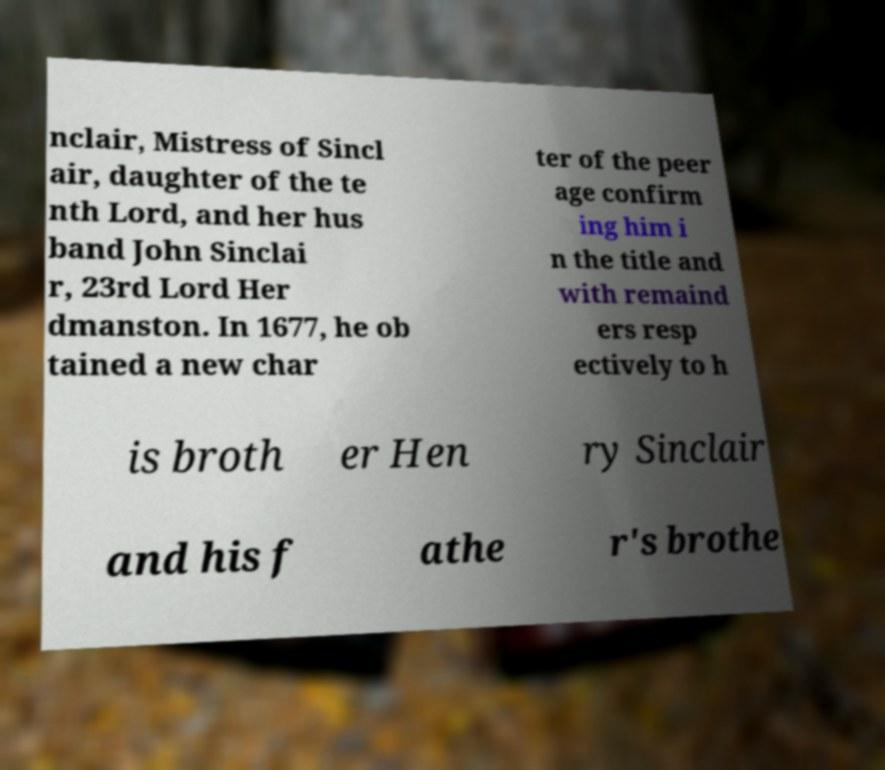Can you read and provide the text displayed in the image?This photo seems to have some interesting text. Can you extract and type it out for me? nclair, Mistress of Sincl air, daughter of the te nth Lord, and her hus band John Sinclai r, 23rd Lord Her dmanston. In 1677, he ob tained a new char ter of the peer age confirm ing him i n the title and with remaind ers resp ectively to h is broth er Hen ry Sinclair and his f athe r's brothe 